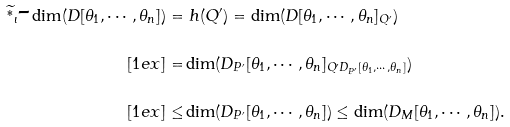<formula> <loc_0><loc_0><loc_500><loc_500>\widetilde { ^ { * } } _ { \iota } \text {-} \dim ( D [ \theta _ { 1 } , \cdots , \theta _ { n } ] ) = & \ h ( Q ^ { \prime } ) = \dim ( D [ \theta _ { 1 } , \cdots , \theta _ { n } ] _ { Q ^ { \prime } } ) \\ [ 1 e x ] = & \dim ( D _ { P ^ { \prime } } [ \theta _ { 1 } , \cdots , \theta _ { n } ] _ { Q ^ { \prime } D _ { P ^ { \prime } } [ \theta _ { 1 } , \cdots , \theta _ { n } ] } ) \\ [ 1 e x ] \leq & \dim ( D _ { P ^ { \prime } } [ \theta _ { 1 } , \cdots , \theta _ { n } ] ) \leq \dim ( D _ { M } [ \theta _ { 1 } , \cdots , \theta _ { n } ] ) .</formula> 